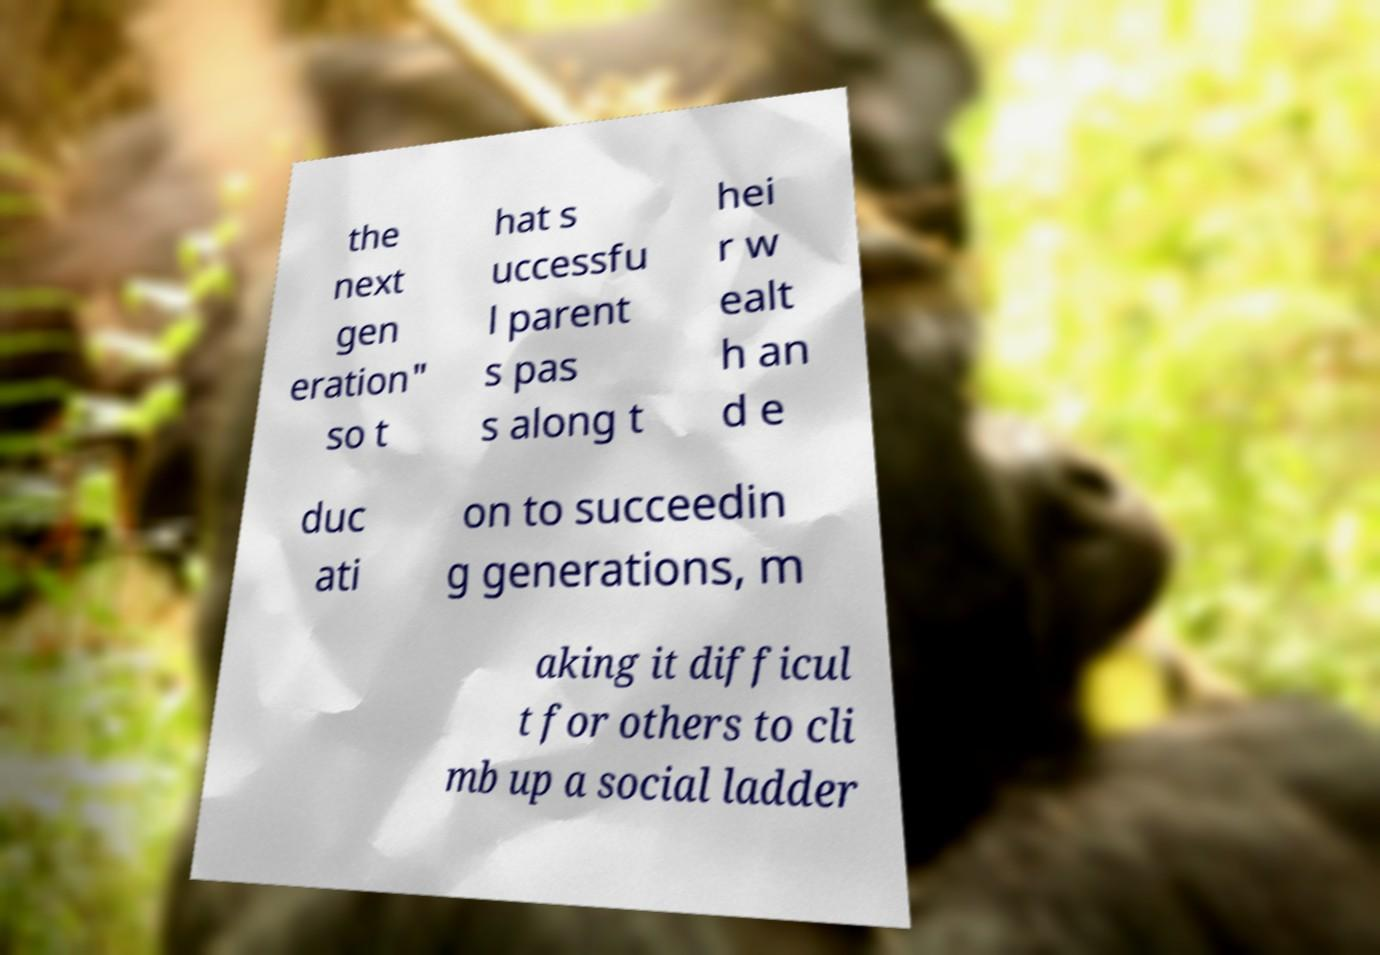Please identify and transcribe the text found in this image. the next gen eration" so t hat s uccessfu l parent s pas s along t hei r w ealt h an d e duc ati on to succeedin g generations, m aking it difficul t for others to cli mb up a social ladder 